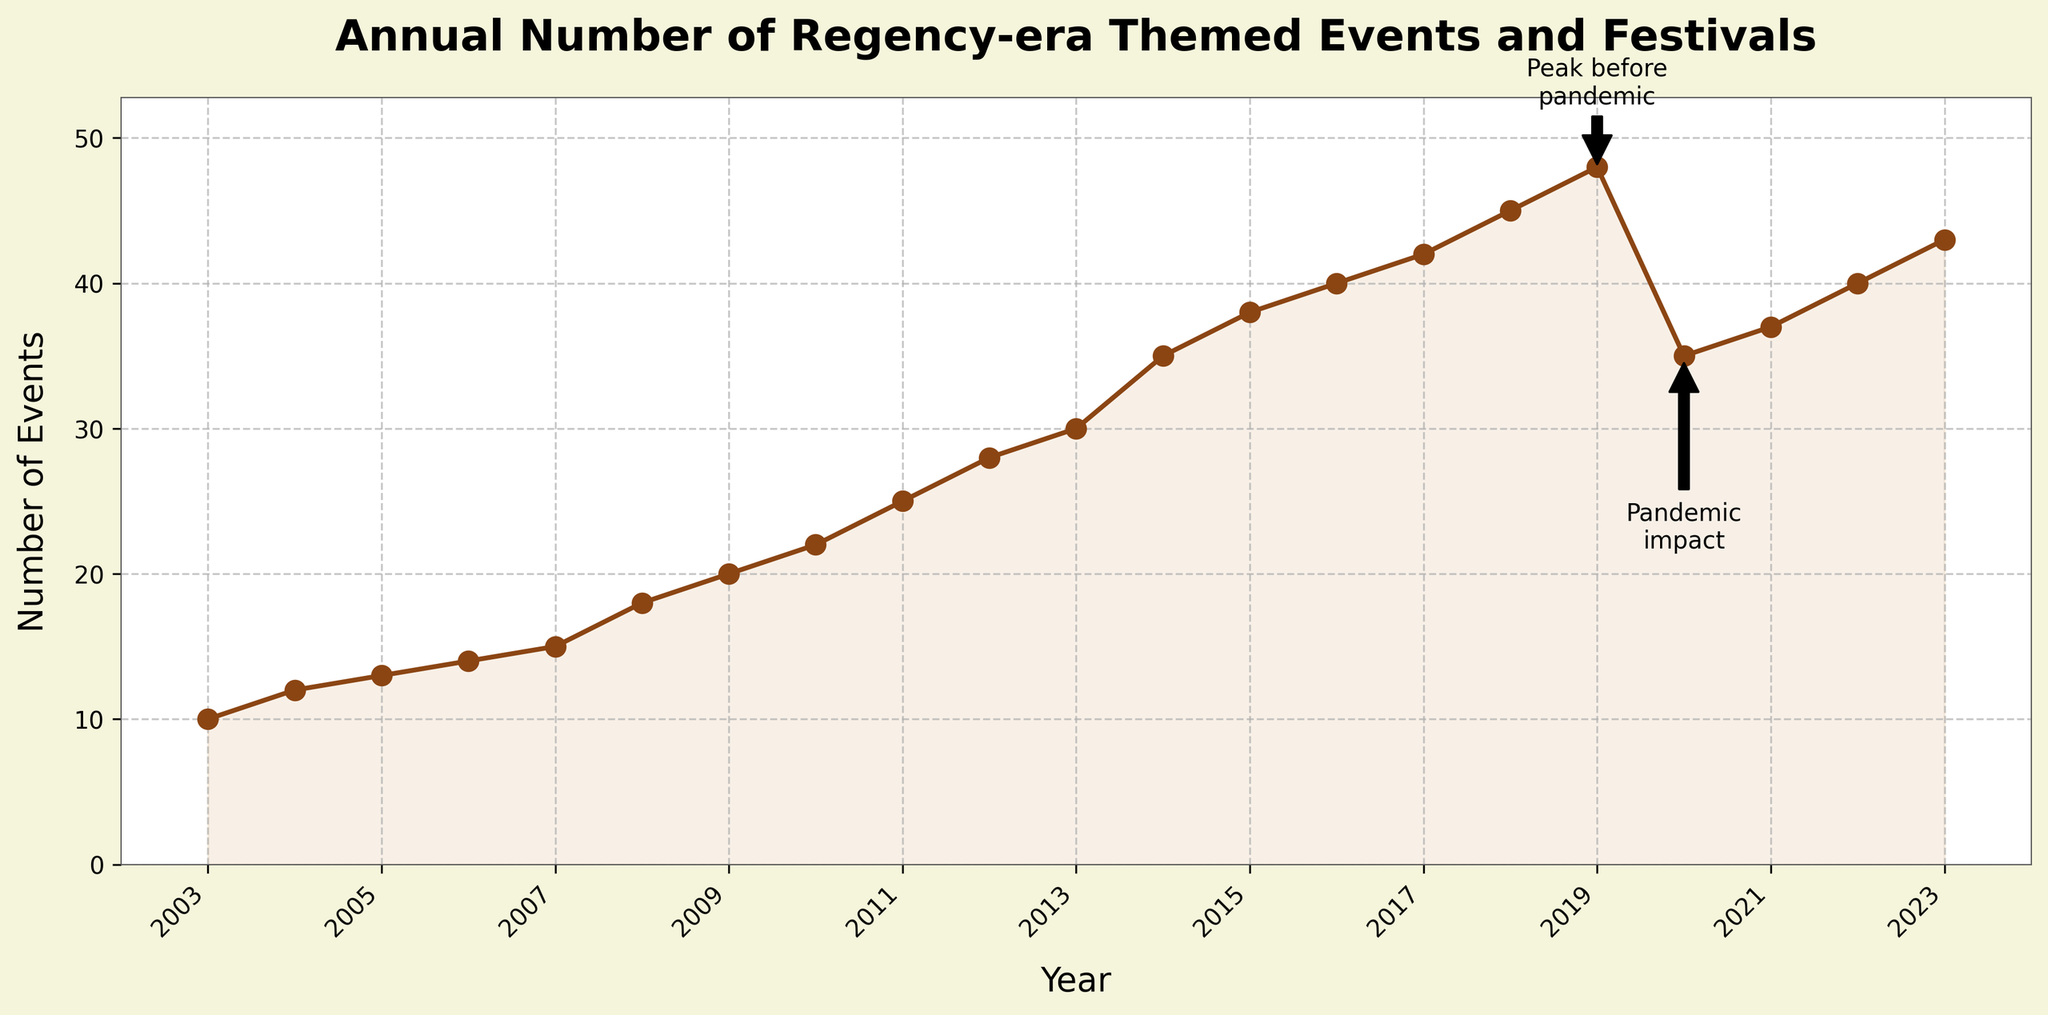What is the title of the figure? The title is usually displayed at the top of the plot. Here, it reads "Annual Number of Regency-era Themed Events and Festivals."
Answer: Annual Number of Regency-era Themed Events and Festivals What is the highest value recorded for the number of events? By looking at the plot, the highest value can be identified as the peak in 2019 which is labeled specifically.
Answer: 48 What happened to the number of events between 2019 and 2020? The plot shows a significant drop from 2019 to 2020. Annotated as 'Pandemic impact,' the events decreased from 48 to 35.
Answer: A decrease What is the general trend in the number of events from 2003 to 2019? From 2003 to 2019, the number of events generally increased each year, showing a consistent upward trend.
Answer: An increase How many events were recorded in 2012? According to the plot, there were 28 events recorded in 2012.
Answer: 28 What years experienced the smallest and largest jumps in the number of events? The smallest jump can be between 2004 and 2005, and the largest jump between 2018 and 2019, as indicated by the steeper slopes.
Answer: Smallest: 2004-2005, Largest: 2018-2019 Compare the number of events in 2020 and 2023. The number of events increased from 35 in 2020 to 43 in 2023. Looking at the y-axis and the years on the x-axis, we see the values rising each year.
Answer: 2023 has more events How did the number of events recover post-2020? After 2020, the figure shows a gradual increase in the number of events from 35 to 43 by 2023.
Answer: Gradual increase Between which consecutive years did the number of events increase by the same amount? The number of events increased by 2 between 2003-2004 and again between 2004-2005 as seen by the consistent increase along the y-axis for these years.
Answer: 2003-2004 and 2004-2005 What's the total number of events from 2010 to 2015? Summing the values for each year from 2010 (22), 2011 (25), 2012 (28), 2013 (30), 2014 (35), to 2015 (38), we get 22 + 25 + 28 + 30 + 35 + 38 = 178.
Answer: 178 